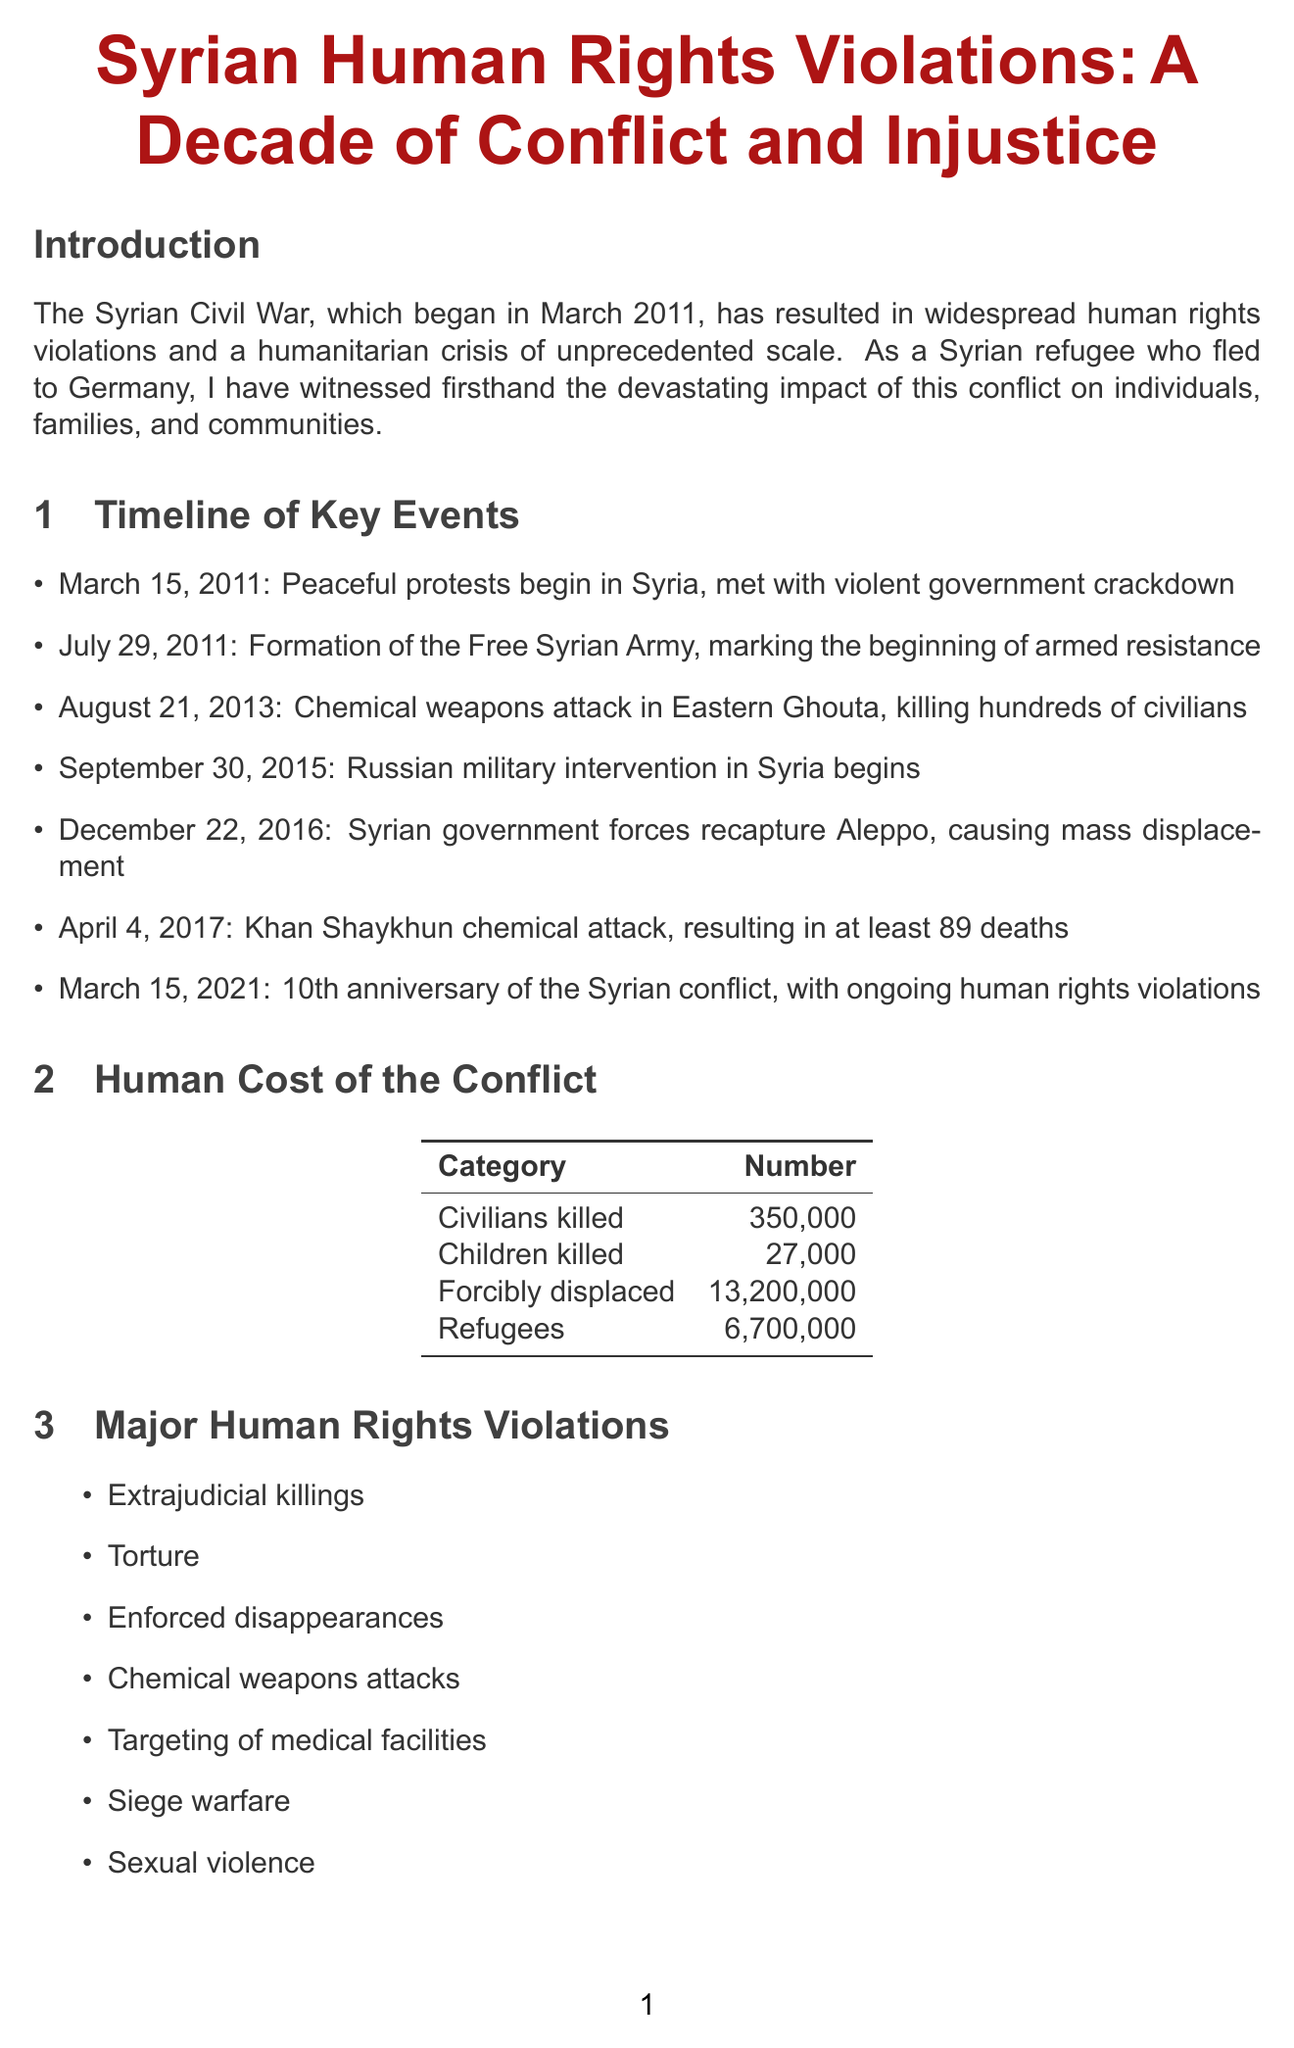What date did the Syrian Civil War begin? The document states that the Syrian Civil War began in March 2011.
Answer: March 15, 2011 How many civilians have been killed in the Syrian Civil War? The report includes a statistic indicating that 350,000 civilians have been killed.
Answer: 350000 What organization was established by the United Nations to investigate human rights violations? The document mentions the establishment of the Independent International Commission of Inquiry on the Syrian Arab Republic.
Answer: Independent International Commission of Inquiry Who is Amira Khaled? Amira Khaled is a case study of a 28-year-old woman from Homs who lost her family in a government airstrike.
Answer: 28-year-old woman from Homs What significant event occurred on December 22, 2016? The report describes that Syrian government forces recaptured Aleppo, leading to mass displacement.
Answer: Syrian government forces recapture Aleppo What major violation is associated with chemical weapons attacks? The document lists chemical weapons attacks as a major human rights violation suffered during the conflict.
Answer: Chemical weapons attacks How many forcibly displaced individuals are there? The report specifies that there are 13,200,000 forcibly displaced individuals due to the conflict.
Answer: 13200000 What was Mahmoud Al-Ali's profession before his detention? The report identifies Mahmoud Al-Ali as a former teacher before he was detained and tortured.
Answer: Teacher 